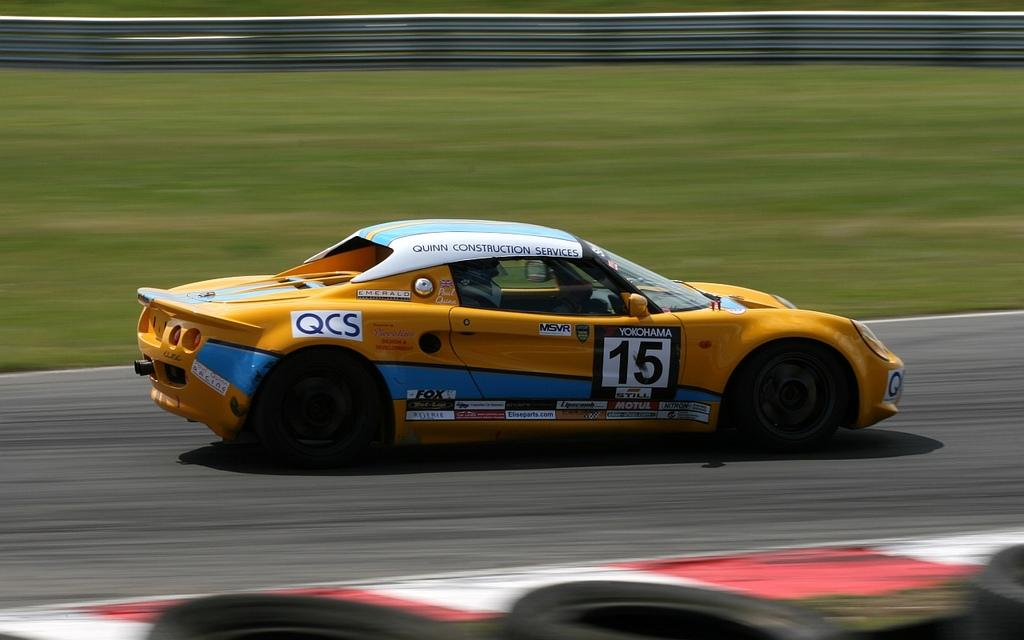What is the main subject of the image? The main subject of the image is a car. What colors are used to paint the car? The car is orange and blue in color. Can you describe the person inside the car? There is a person inside the car, but their appearance cannot be determined from the image. What type of vegetation is visible in the background of the image? The background of the image includes grass. What is the color of the grass? The grass is green in color. What songs can be heard playing from the car's radio in the image? There is no information about the car's radio or any songs playing in the image. In which direction is the car traveling in the image? The direction in which the car is traveling cannot be determined from the image, as it is stationary. 